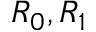Convert formula to latex. <formula><loc_0><loc_0><loc_500><loc_500>R _ { 0 } , R _ { 1 }</formula> 